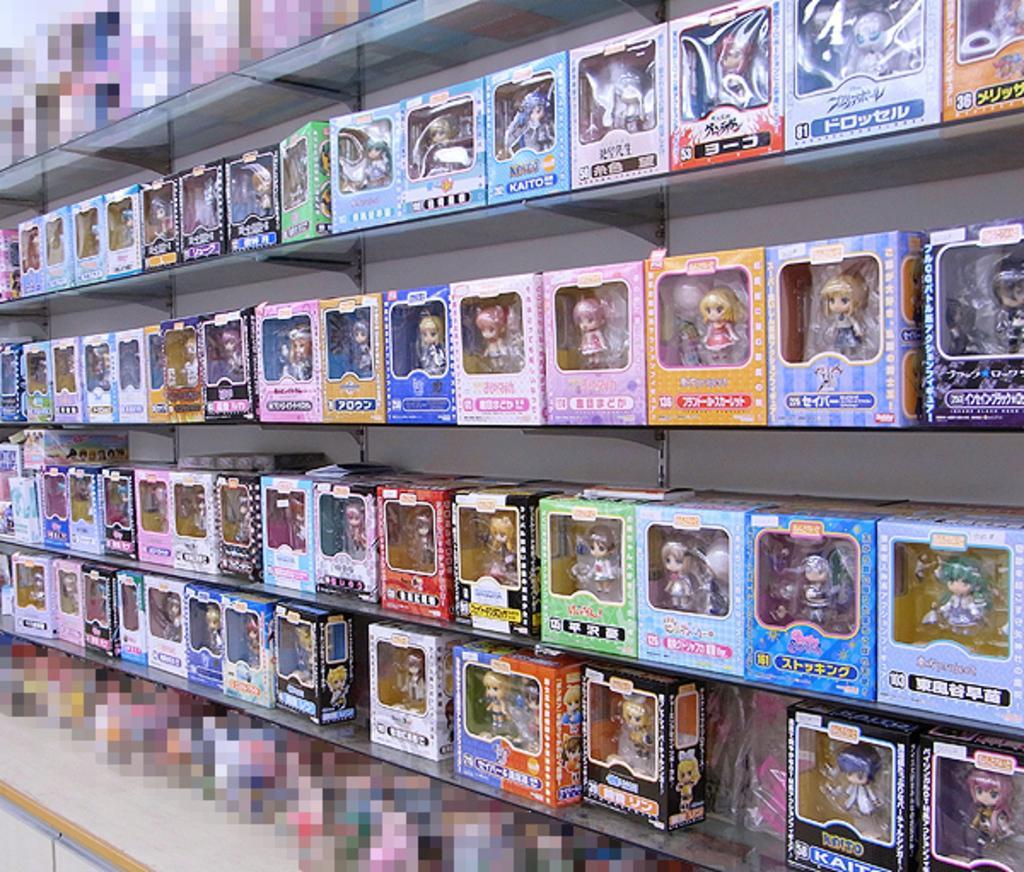How would you summarize this image in a sentence or two? In this image there are toys in the center which is kept on the shelfs. 